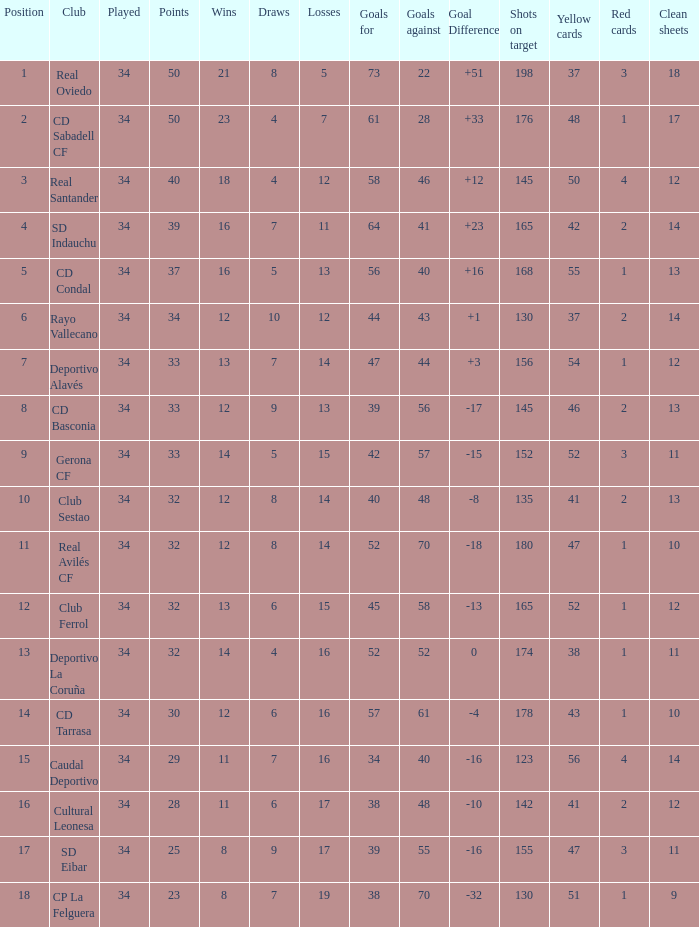Which Wins have a Goal Difference larger than 0, and Goals against larger than 40, and a Position smaller than 6, and a Club of sd indauchu? 16.0. 